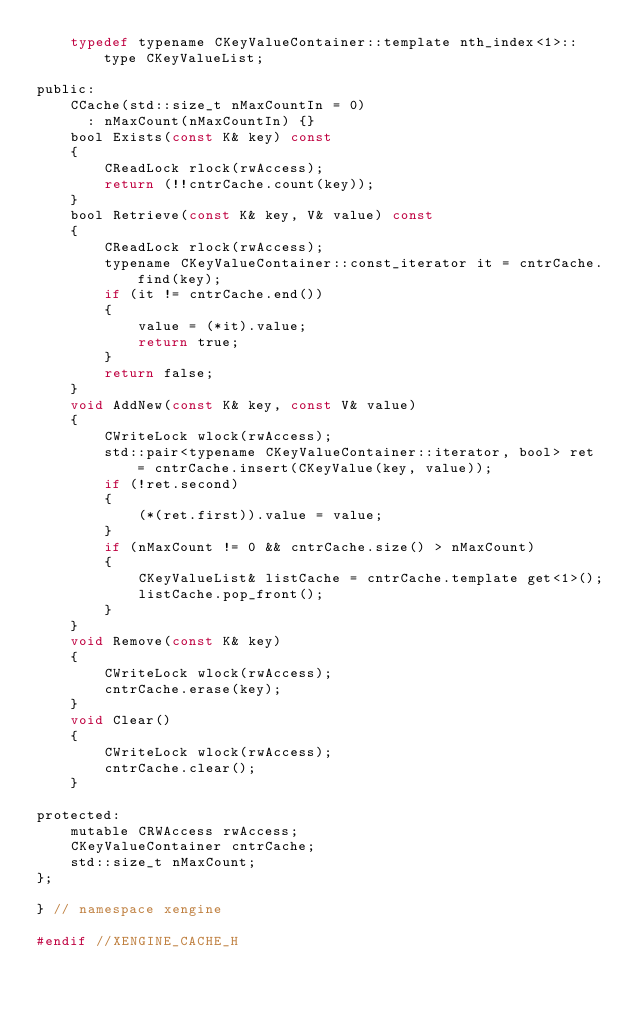<code> <loc_0><loc_0><loc_500><loc_500><_C_>    typedef typename CKeyValueContainer::template nth_index<1>::type CKeyValueList;

public:
    CCache(std::size_t nMaxCountIn = 0)
      : nMaxCount(nMaxCountIn) {}
    bool Exists(const K& key) const
    {
        CReadLock rlock(rwAccess);
        return (!!cntrCache.count(key));
    }
    bool Retrieve(const K& key, V& value) const
    {
        CReadLock rlock(rwAccess);
        typename CKeyValueContainer::const_iterator it = cntrCache.find(key);
        if (it != cntrCache.end())
        {
            value = (*it).value;
            return true;
        }
        return false;
    }
    void AddNew(const K& key, const V& value)
    {
        CWriteLock wlock(rwAccess);
        std::pair<typename CKeyValueContainer::iterator, bool> ret = cntrCache.insert(CKeyValue(key, value));
        if (!ret.second)
        {
            (*(ret.first)).value = value;
        }
        if (nMaxCount != 0 && cntrCache.size() > nMaxCount)
        {
            CKeyValueList& listCache = cntrCache.template get<1>();
            listCache.pop_front();
        }
    }
    void Remove(const K& key)
    {
        CWriteLock wlock(rwAccess);
        cntrCache.erase(key);
    }
    void Clear()
    {
        CWriteLock wlock(rwAccess);
        cntrCache.clear();
    }

protected:
    mutable CRWAccess rwAccess;
    CKeyValueContainer cntrCache;
    std::size_t nMaxCount;
};

} // namespace xengine

#endif //XENGINE_CACHE_H
</code> 